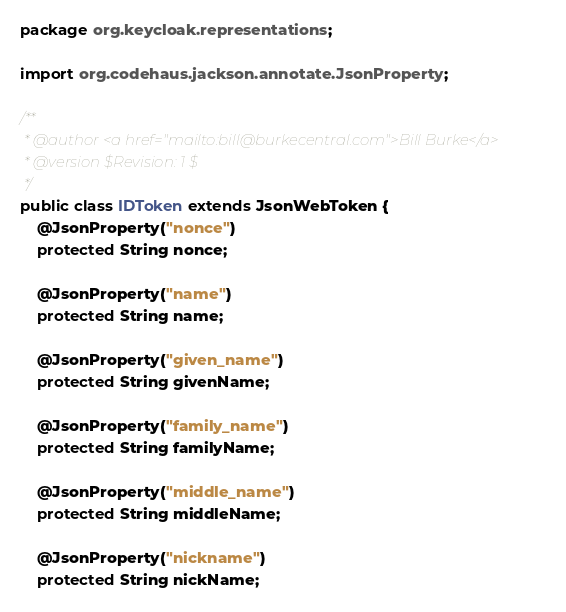<code> <loc_0><loc_0><loc_500><loc_500><_Java_>package org.keycloak.representations;

import org.codehaus.jackson.annotate.JsonProperty;

/**
 * @author <a href="mailto:bill@burkecentral.com">Bill Burke</a>
 * @version $Revision: 1 $
 */
public class IDToken extends JsonWebToken {
    @JsonProperty("nonce")
    protected String nonce;

    @JsonProperty("name")
    protected String name;

    @JsonProperty("given_name")
    protected String givenName;

    @JsonProperty("family_name")
    protected String familyName;

    @JsonProperty("middle_name")
    protected String middleName;

    @JsonProperty("nickname")
    protected String nickName;
</code> 